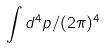<formula> <loc_0><loc_0><loc_500><loc_500>\int d ^ { 4 } p / ( 2 \pi ) ^ { 4 }</formula> 